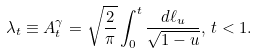<formula> <loc_0><loc_0><loc_500><loc_500>\lambda _ { t } \equiv A _ { t } ^ { \gamma } = \sqrt { \frac { 2 } { \pi } } \int _ { 0 } ^ { t } \frac { d \ell _ { u } } { \sqrt { 1 - u } } , \, t < 1 .</formula> 